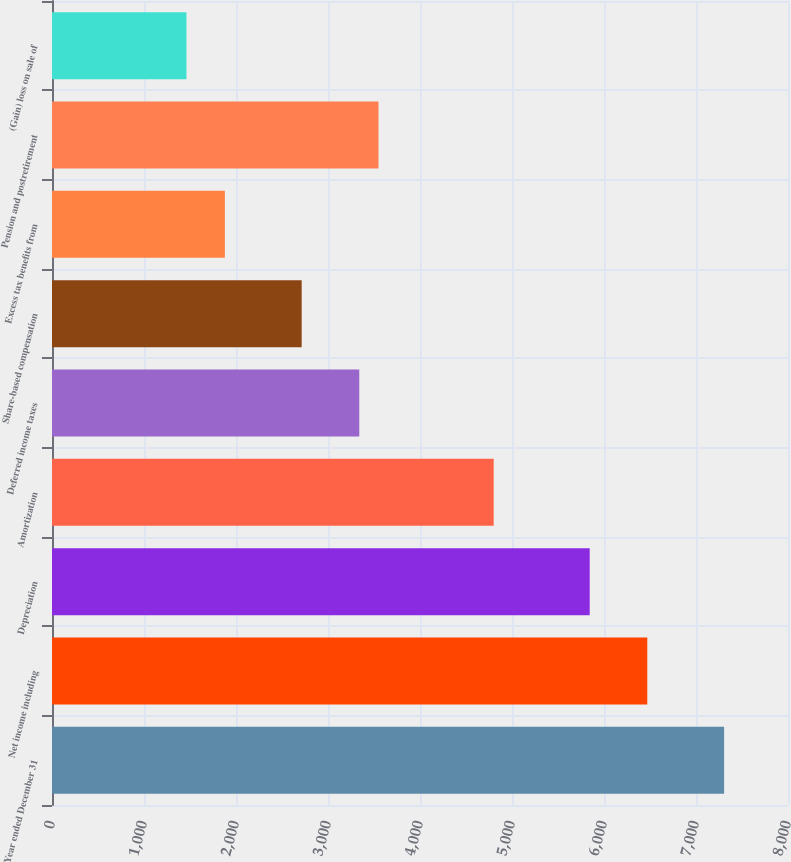<chart> <loc_0><loc_0><loc_500><loc_500><bar_chart><fcel>Year ended December 31<fcel>Net income including<fcel>Depreciation<fcel>Amortization<fcel>Deferred income taxes<fcel>Share-based compensation<fcel>Excess tax benefits from<fcel>Pension and postretirement<fcel>(Gain) loss on sale of<nl><fcel>7305.45<fcel>6470.61<fcel>5844.48<fcel>4800.93<fcel>3339.96<fcel>2713.83<fcel>1878.99<fcel>3548.67<fcel>1461.57<nl></chart> 